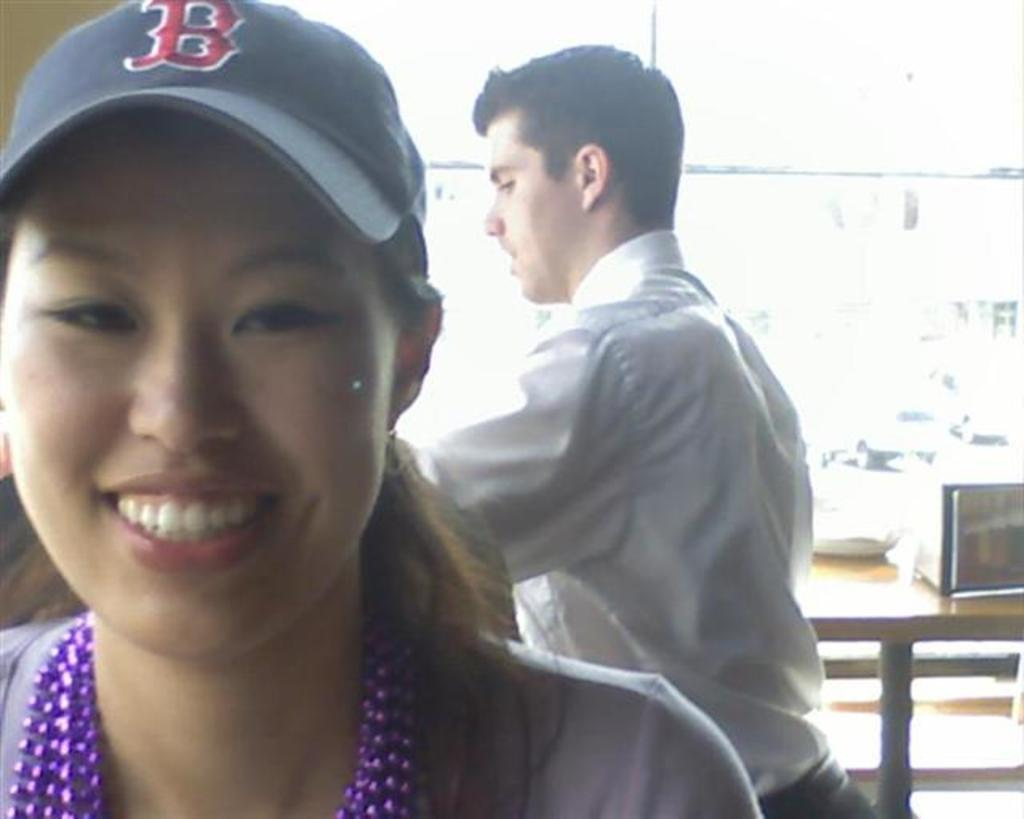<image>
Summarize the visual content of the image. Woman that is wearing a Boston Red Sox hat with a man in the back of her. 